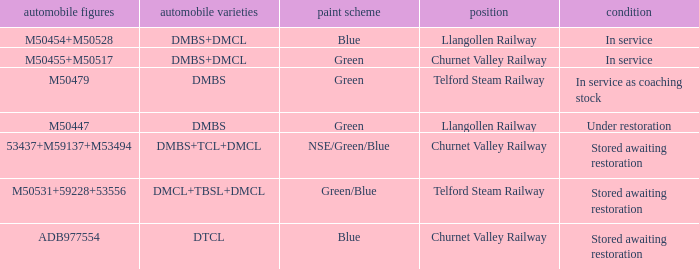What livery has a status of in service as coaching stock? Green. 